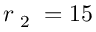<formula> <loc_0><loc_0><loc_500><loc_500>r _ { 2 } = 1 5</formula> 